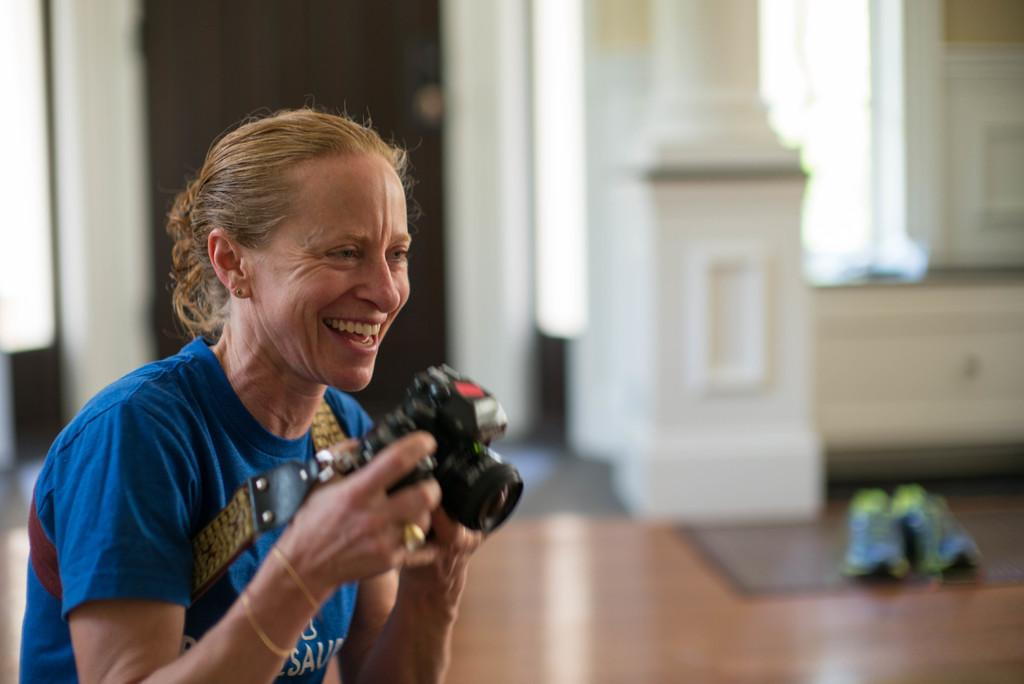What color is the t-shirt the person is wearing in the image? The person is wearing a blue t-shirt in the image. What is the person holding in her hand? The person is holding a camera in her hand. What expression does the person have on her face? The person is smiling in the image. What can be seen in the background of the image? There is a white pillar, a white wall, and a door in the background. What is on the floor at the right side of the image? There are shoes on the floor at the right side of the image. What type of carriage can be seen in the image? There is no carriage present in the image. Is the person in the image preparing for a flight? There is no indication in the image that the person is preparing for a flight. 